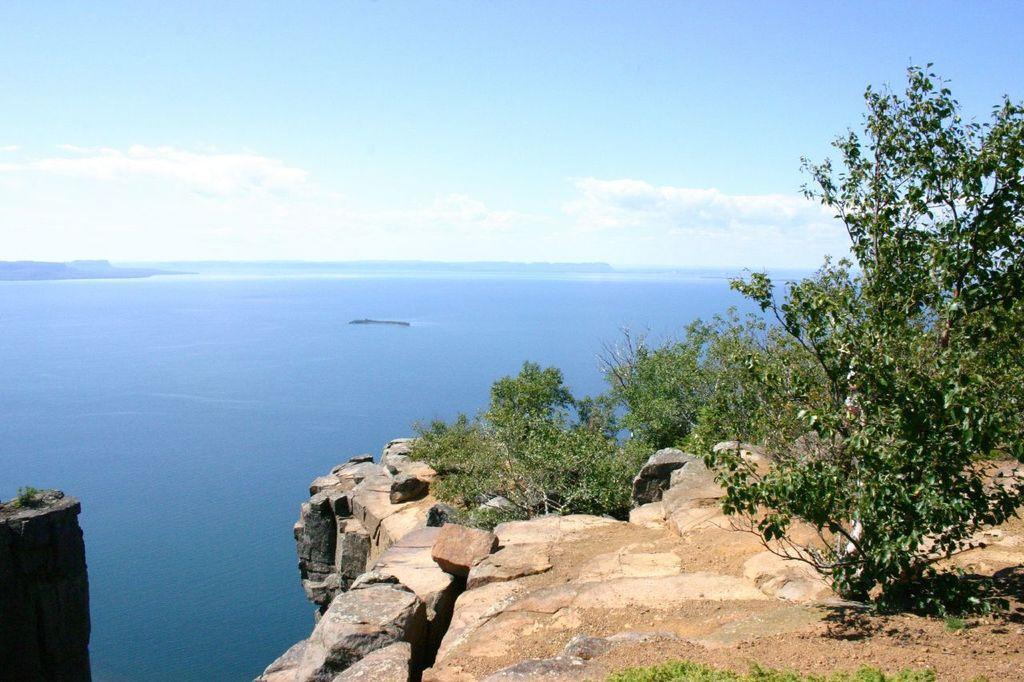How would you summarize this image in a sentence or two? In the image we can see the sea, rocks, plants, grass, trees and the cloudy sky. 